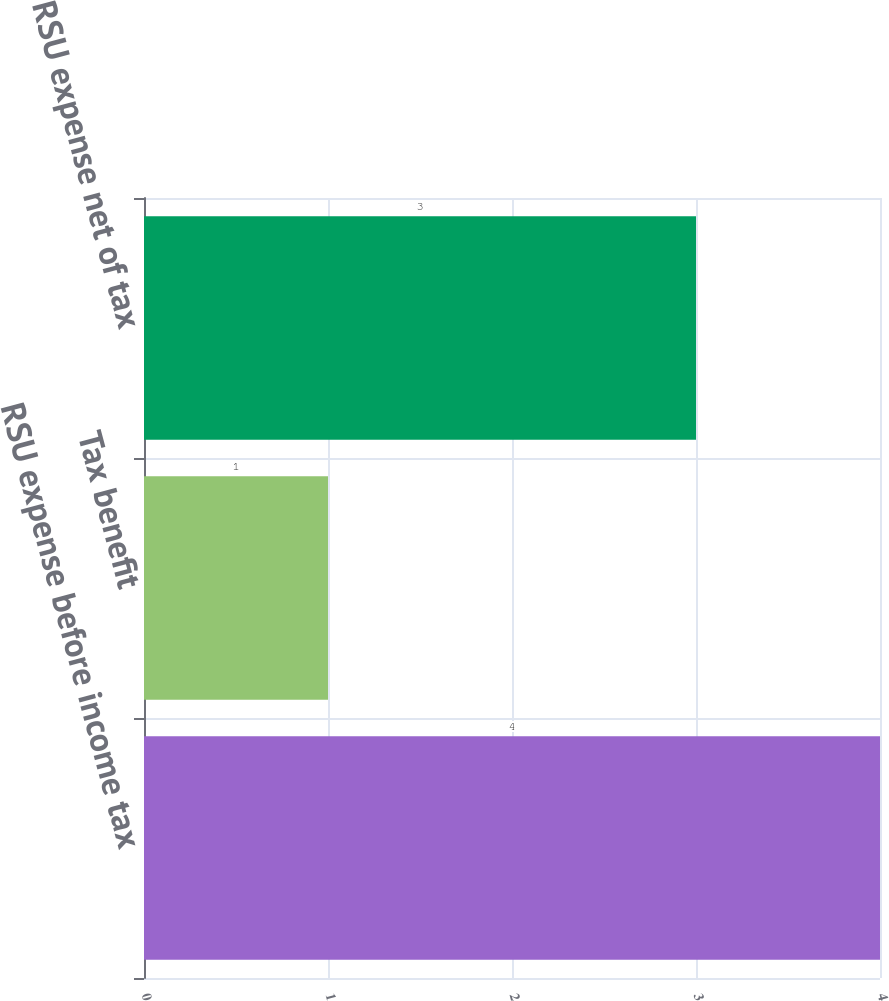<chart> <loc_0><loc_0><loc_500><loc_500><bar_chart><fcel>RSU expense before income tax<fcel>Tax benefit<fcel>RSU expense net of tax<nl><fcel>4<fcel>1<fcel>3<nl></chart> 